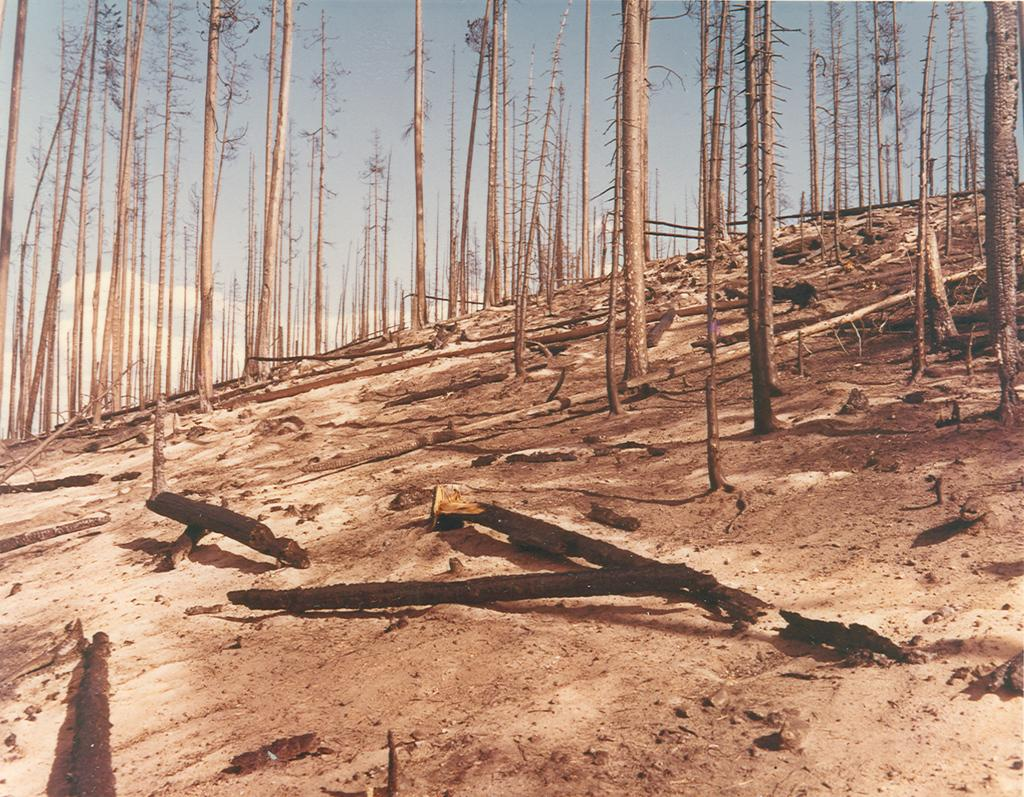What type of vegetation can be seen on the hill in the image? There are trees on a hill in the image. What can be found on the ground near the trees? There are fallen barks in the image. What is visible in the background of the image? The sky is visible in the background of the image. What can be observed in the sky? There are clouds in the sky. What type of apparatus is being used to cook the fallen barks in the image? There is no apparatus or cooking activity present in the image; it only features trees, fallen barks, and the sky. Can you see the toes of the person who took the picture in the image? There is no person or their toes visible in the image. 